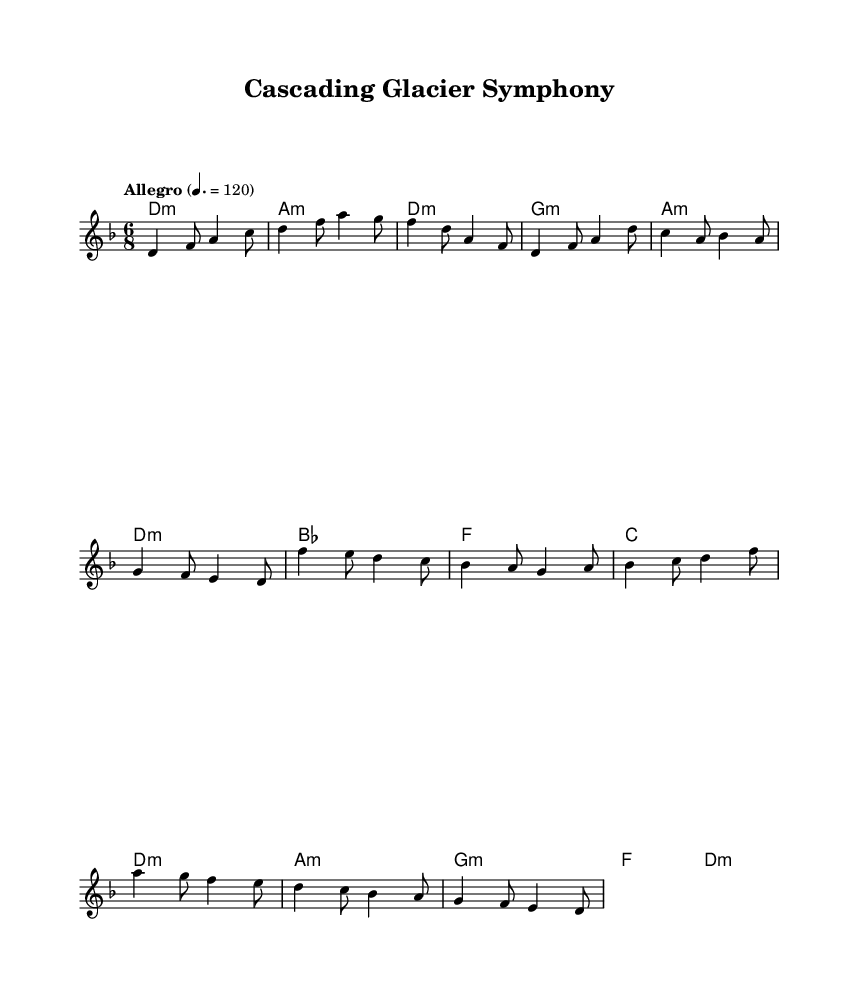What is the key signature of this music? The key signature is D minor, which typically has one flat (B flat). This can be inferred from the presence of the D note in the melody and the key designation at the beginning of the score.
Answer: D minor What is the time signature of this piece? The time signature is 6/8, indicating that there are six eighth notes in each measure. This is visible at the beginning of the score where the time signature is clearly marked.
Answer: 6/8 What is the tempo of the piece? The tempo is marked as "Allegro" with a metronome marking of 120 beats per minute. This can be identified in the tempo marking at the top of the score, indicating the speed of the music.
Answer: Allegro, 120 How many measures are in the intro section? The intro section contains three measures as indicated by the number of distinct units of music before the verse begins. Counting the measures visually shows that there are indeed three before any further sections of the piece.
Answer: 3 What type of tonality is primarily used in the chorus? The tonality primarily used in the chorus is D minor, as indicated by the chords and the overall melody that revolve around D minor notes. The presence of D in the melody during the chorus reinforces this tonality.
Answer: D minor Which musical element features the phrase "Cascading Glacier Symphony"? The title "Cascading Glacier Symphony" is featured as the header at the top of the sheet music, indicating the name of the composition. This is typically the first thing seen in the score layout.
Answer: Title Name one chord used during the bridge section. One of the chords used during the bridge section is F major. This can be seen in the chord progression provided within the harmonies section where specific chords are listed.
Answer: F major 